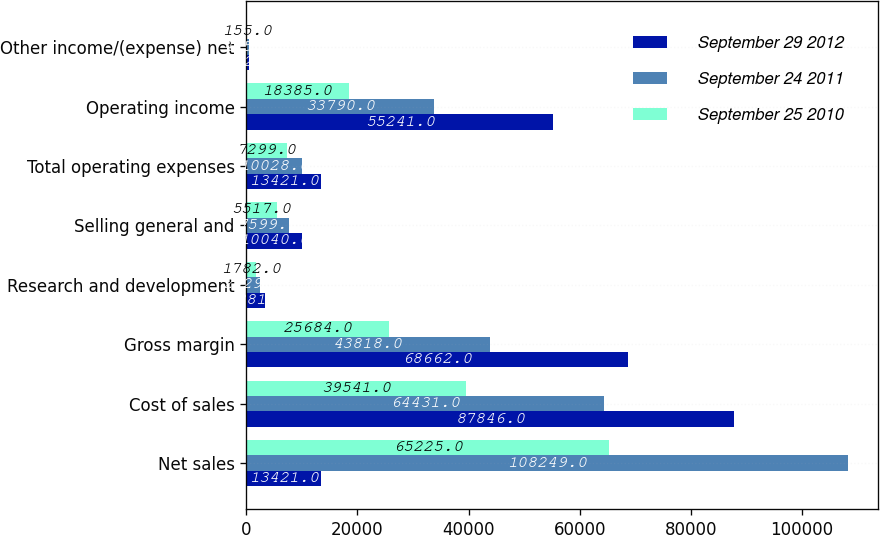<chart> <loc_0><loc_0><loc_500><loc_500><stacked_bar_chart><ecel><fcel>Net sales<fcel>Cost of sales<fcel>Gross margin<fcel>Research and development<fcel>Selling general and<fcel>Total operating expenses<fcel>Operating income<fcel>Other income/(expense) net<nl><fcel>September 29 2012<fcel>13421<fcel>87846<fcel>68662<fcel>3381<fcel>10040<fcel>13421<fcel>55241<fcel>522<nl><fcel>September 24 2011<fcel>108249<fcel>64431<fcel>43818<fcel>2429<fcel>7599<fcel>10028<fcel>33790<fcel>415<nl><fcel>September 25 2010<fcel>65225<fcel>39541<fcel>25684<fcel>1782<fcel>5517<fcel>7299<fcel>18385<fcel>155<nl></chart> 